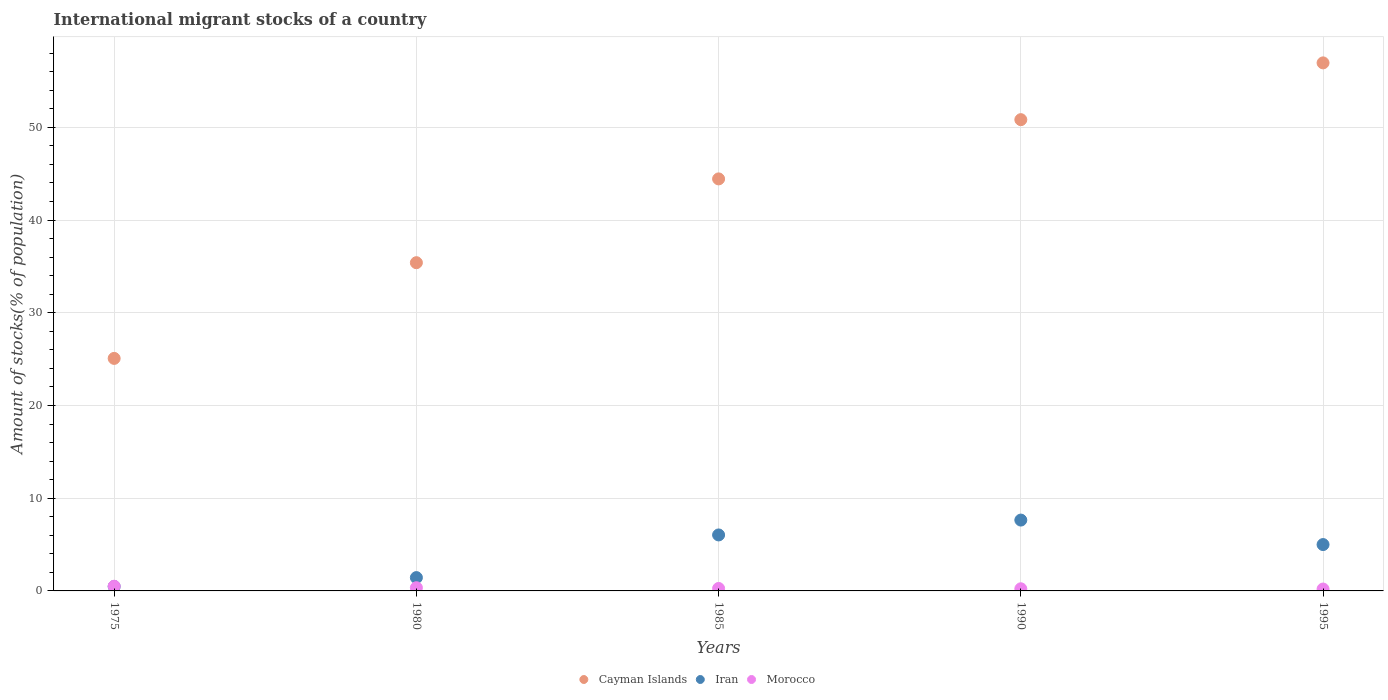How many different coloured dotlines are there?
Provide a short and direct response. 3. What is the amount of stocks in in Morocco in 1995?
Keep it short and to the point. 0.2. Across all years, what is the maximum amount of stocks in in Iran?
Your response must be concise. 7.64. Across all years, what is the minimum amount of stocks in in Cayman Islands?
Give a very brief answer. 25.08. In which year was the amount of stocks in in Cayman Islands minimum?
Your answer should be very brief. 1975. What is the total amount of stocks in in Morocco in the graph?
Your answer should be compact. 1.55. What is the difference between the amount of stocks in in Iran in 1975 and that in 1980?
Offer a terse response. -0.96. What is the difference between the amount of stocks in in Morocco in 1985 and the amount of stocks in in Iran in 1980?
Provide a short and direct response. -1.17. What is the average amount of stocks in in Iran per year?
Offer a very short reply. 4.12. In the year 1975, what is the difference between the amount of stocks in in Iran and amount of stocks in in Cayman Islands?
Provide a short and direct response. -24.6. In how many years, is the amount of stocks in in Iran greater than 34 %?
Your answer should be compact. 0. What is the ratio of the amount of stocks in in Cayman Islands in 1980 to that in 1995?
Offer a very short reply. 0.62. Is the difference between the amount of stocks in in Iran in 1975 and 1995 greater than the difference between the amount of stocks in in Cayman Islands in 1975 and 1995?
Your answer should be compact. Yes. What is the difference between the highest and the second highest amount of stocks in in Cayman Islands?
Provide a succinct answer. 6.12. What is the difference between the highest and the lowest amount of stocks in in Cayman Islands?
Your answer should be compact. 31.87. In how many years, is the amount of stocks in in Morocco greater than the average amount of stocks in in Morocco taken over all years?
Provide a short and direct response. 2. Is the sum of the amount of stocks in in Iran in 1985 and 1995 greater than the maximum amount of stocks in in Cayman Islands across all years?
Your answer should be very brief. No. Is it the case that in every year, the sum of the amount of stocks in in Iran and amount of stocks in in Cayman Islands  is greater than the amount of stocks in in Morocco?
Your response must be concise. Yes. How many dotlines are there?
Give a very brief answer. 3. What is the difference between two consecutive major ticks on the Y-axis?
Your answer should be very brief. 10. Are the values on the major ticks of Y-axis written in scientific E-notation?
Offer a very short reply. No. Does the graph contain grids?
Offer a terse response. Yes. How many legend labels are there?
Ensure brevity in your answer.  3. What is the title of the graph?
Make the answer very short. International migrant stocks of a country. Does "Mauritania" appear as one of the legend labels in the graph?
Make the answer very short. No. What is the label or title of the X-axis?
Provide a short and direct response. Years. What is the label or title of the Y-axis?
Your answer should be compact. Amount of stocks(% of population). What is the Amount of stocks(% of population) in Cayman Islands in 1975?
Offer a terse response. 25.08. What is the Amount of stocks(% of population) of Iran in 1975?
Your response must be concise. 0.48. What is the Amount of stocks(% of population) of Morocco in 1975?
Make the answer very short. 0.51. What is the Amount of stocks(% of population) of Cayman Islands in 1980?
Keep it short and to the point. 35.4. What is the Amount of stocks(% of population) in Iran in 1980?
Give a very brief answer. 1.44. What is the Amount of stocks(% of population) of Morocco in 1980?
Your answer should be compact. 0.34. What is the Amount of stocks(% of population) in Cayman Islands in 1985?
Your answer should be compact. 44.44. What is the Amount of stocks(% of population) in Iran in 1985?
Your response must be concise. 6.04. What is the Amount of stocks(% of population) in Morocco in 1985?
Your answer should be very brief. 0.27. What is the Amount of stocks(% of population) in Cayman Islands in 1990?
Keep it short and to the point. 50.83. What is the Amount of stocks(% of population) of Iran in 1990?
Your answer should be very brief. 7.64. What is the Amount of stocks(% of population) of Morocco in 1990?
Give a very brief answer. 0.23. What is the Amount of stocks(% of population) in Cayman Islands in 1995?
Your answer should be compact. 56.95. What is the Amount of stocks(% of population) in Iran in 1995?
Ensure brevity in your answer.  5. What is the Amount of stocks(% of population) of Morocco in 1995?
Provide a succinct answer. 0.2. Across all years, what is the maximum Amount of stocks(% of population) of Cayman Islands?
Ensure brevity in your answer.  56.95. Across all years, what is the maximum Amount of stocks(% of population) in Iran?
Provide a short and direct response. 7.64. Across all years, what is the maximum Amount of stocks(% of population) of Morocco?
Provide a short and direct response. 0.51. Across all years, what is the minimum Amount of stocks(% of population) in Cayman Islands?
Provide a short and direct response. 25.08. Across all years, what is the minimum Amount of stocks(% of population) in Iran?
Your answer should be very brief. 0.48. Across all years, what is the minimum Amount of stocks(% of population) of Morocco?
Ensure brevity in your answer.  0.2. What is the total Amount of stocks(% of population) of Cayman Islands in the graph?
Give a very brief answer. 212.69. What is the total Amount of stocks(% of population) of Iran in the graph?
Make the answer very short. 20.59. What is the total Amount of stocks(% of population) of Morocco in the graph?
Your answer should be very brief. 1.55. What is the difference between the Amount of stocks(% of population) of Cayman Islands in 1975 and that in 1980?
Your answer should be compact. -10.32. What is the difference between the Amount of stocks(% of population) in Iran in 1975 and that in 1980?
Make the answer very short. -0.96. What is the difference between the Amount of stocks(% of population) of Morocco in 1975 and that in 1980?
Provide a short and direct response. 0.16. What is the difference between the Amount of stocks(% of population) of Cayman Islands in 1975 and that in 1985?
Provide a succinct answer. -19.36. What is the difference between the Amount of stocks(% of population) of Iran in 1975 and that in 1985?
Provide a short and direct response. -5.56. What is the difference between the Amount of stocks(% of population) of Morocco in 1975 and that in 1985?
Make the answer very short. 0.24. What is the difference between the Amount of stocks(% of population) of Cayman Islands in 1975 and that in 1990?
Provide a short and direct response. -25.75. What is the difference between the Amount of stocks(% of population) in Iran in 1975 and that in 1990?
Give a very brief answer. -7.16. What is the difference between the Amount of stocks(% of population) in Morocco in 1975 and that in 1990?
Provide a succinct answer. 0.28. What is the difference between the Amount of stocks(% of population) of Cayman Islands in 1975 and that in 1995?
Offer a very short reply. -31.87. What is the difference between the Amount of stocks(% of population) of Iran in 1975 and that in 1995?
Ensure brevity in your answer.  -4.52. What is the difference between the Amount of stocks(% of population) of Morocco in 1975 and that in 1995?
Your answer should be very brief. 0.3. What is the difference between the Amount of stocks(% of population) in Cayman Islands in 1980 and that in 1985?
Make the answer very short. -9.04. What is the difference between the Amount of stocks(% of population) of Iran in 1980 and that in 1985?
Provide a succinct answer. -4.6. What is the difference between the Amount of stocks(% of population) of Morocco in 1980 and that in 1985?
Keep it short and to the point. 0.08. What is the difference between the Amount of stocks(% of population) in Cayman Islands in 1980 and that in 1990?
Your answer should be compact. -15.43. What is the difference between the Amount of stocks(% of population) in Iran in 1980 and that in 1990?
Give a very brief answer. -6.2. What is the difference between the Amount of stocks(% of population) in Morocco in 1980 and that in 1990?
Provide a short and direct response. 0.11. What is the difference between the Amount of stocks(% of population) in Cayman Islands in 1980 and that in 1995?
Your response must be concise. -21.55. What is the difference between the Amount of stocks(% of population) in Iran in 1980 and that in 1995?
Make the answer very short. -3.56. What is the difference between the Amount of stocks(% of population) of Morocco in 1980 and that in 1995?
Your answer should be very brief. 0.14. What is the difference between the Amount of stocks(% of population) of Cayman Islands in 1985 and that in 1990?
Provide a short and direct response. -6.39. What is the difference between the Amount of stocks(% of population) in Iran in 1985 and that in 1990?
Keep it short and to the point. -1.6. What is the difference between the Amount of stocks(% of population) of Morocco in 1985 and that in 1990?
Ensure brevity in your answer.  0.03. What is the difference between the Amount of stocks(% of population) of Cayman Islands in 1985 and that in 1995?
Make the answer very short. -12.51. What is the difference between the Amount of stocks(% of population) in Iran in 1985 and that in 1995?
Keep it short and to the point. 1.04. What is the difference between the Amount of stocks(% of population) in Morocco in 1985 and that in 1995?
Provide a succinct answer. 0.06. What is the difference between the Amount of stocks(% of population) of Cayman Islands in 1990 and that in 1995?
Offer a terse response. -6.12. What is the difference between the Amount of stocks(% of population) of Iran in 1990 and that in 1995?
Give a very brief answer. 2.64. What is the difference between the Amount of stocks(% of population) in Morocco in 1990 and that in 1995?
Provide a short and direct response. 0.03. What is the difference between the Amount of stocks(% of population) of Cayman Islands in 1975 and the Amount of stocks(% of population) of Iran in 1980?
Offer a terse response. 23.64. What is the difference between the Amount of stocks(% of population) in Cayman Islands in 1975 and the Amount of stocks(% of population) in Morocco in 1980?
Keep it short and to the point. 24.73. What is the difference between the Amount of stocks(% of population) in Iran in 1975 and the Amount of stocks(% of population) in Morocco in 1980?
Give a very brief answer. 0.14. What is the difference between the Amount of stocks(% of population) in Cayman Islands in 1975 and the Amount of stocks(% of population) in Iran in 1985?
Your response must be concise. 19.04. What is the difference between the Amount of stocks(% of population) of Cayman Islands in 1975 and the Amount of stocks(% of population) of Morocco in 1985?
Keep it short and to the point. 24.81. What is the difference between the Amount of stocks(% of population) of Iran in 1975 and the Amount of stocks(% of population) of Morocco in 1985?
Keep it short and to the point. 0.21. What is the difference between the Amount of stocks(% of population) in Cayman Islands in 1975 and the Amount of stocks(% of population) in Iran in 1990?
Offer a terse response. 17.44. What is the difference between the Amount of stocks(% of population) of Cayman Islands in 1975 and the Amount of stocks(% of population) of Morocco in 1990?
Your answer should be compact. 24.85. What is the difference between the Amount of stocks(% of population) in Iran in 1975 and the Amount of stocks(% of population) in Morocco in 1990?
Keep it short and to the point. 0.25. What is the difference between the Amount of stocks(% of population) of Cayman Islands in 1975 and the Amount of stocks(% of population) of Iran in 1995?
Keep it short and to the point. 20.08. What is the difference between the Amount of stocks(% of population) in Cayman Islands in 1975 and the Amount of stocks(% of population) in Morocco in 1995?
Provide a short and direct response. 24.87. What is the difference between the Amount of stocks(% of population) in Iran in 1975 and the Amount of stocks(% of population) in Morocco in 1995?
Make the answer very short. 0.28. What is the difference between the Amount of stocks(% of population) of Cayman Islands in 1980 and the Amount of stocks(% of population) of Iran in 1985?
Offer a terse response. 29.36. What is the difference between the Amount of stocks(% of population) of Cayman Islands in 1980 and the Amount of stocks(% of population) of Morocco in 1985?
Provide a succinct answer. 35.13. What is the difference between the Amount of stocks(% of population) of Iran in 1980 and the Amount of stocks(% of population) of Morocco in 1985?
Make the answer very short. 1.17. What is the difference between the Amount of stocks(% of population) in Cayman Islands in 1980 and the Amount of stocks(% of population) in Iran in 1990?
Make the answer very short. 27.76. What is the difference between the Amount of stocks(% of population) in Cayman Islands in 1980 and the Amount of stocks(% of population) in Morocco in 1990?
Provide a short and direct response. 35.17. What is the difference between the Amount of stocks(% of population) in Iran in 1980 and the Amount of stocks(% of population) in Morocco in 1990?
Your response must be concise. 1.21. What is the difference between the Amount of stocks(% of population) in Cayman Islands in 1980 and the Amount of stocks(% of population) in Iran in 1995?
Provide a short and direct response. 30.4. What is the difference between the Amount of stocks(% of population) of Cayman Islands in 1980 and the Amount of stocks(% of population) of Morocco in 1995?
Your answer should be very brief. 35.2. What is the difference between the Amount of stocks(% of population) of Iran in 1980 and the Amount of stocks(% of population) of Morocco in 1995?
Your answer should be very brief. 1.23. What is the difference between the Amount of stocks(% of population) in Cayman Islands in 1985 and the Amount of stocks(% of population) in Iran in 1990?
Provide a succinct answer. 36.8. What is the difference between the Amount of stocks(% of population) in Cayman Islands in 1985 and the Amount of stocks(% of population) in Morocco in 1990?
Your answer should be compact. 44.21. What is the difference between the Amount of stocks(% of population) of Iran in 1985 and the Amount of stocks(% of population) of Morocco in 1990?
Provide a short and direct response. 5.81. What is the difference between the Amount of stocks(% of population) in Cayman Islands in 1985 and the Amount of stocks(% of population) in Iran in 1995?
Keep it short and to the point. 39.44. What is the difference between the Amount of stocks(% of population) of Cayman Islands in 1985 and the Amount of stocks(% of population) of Morocco in 1995?
Offer a terse response. 44.23. What is the difference between the Amount of stocks(% of population) of Iran in 1985 and the Amount of stocks(% of population) of Morocco in 1995?
Your answer should be very brief. 5.83. What is the difference between the Amount of stocks(% of population) in Cayman Islands in 1990 and the Amount of stocks(% of population) in Iran in 1995?
Offer a terse response. 45.83. What is the difference between the Amount of stocks(% of population) in Cayman Islands in 1990 and the Amount of stocks(% of population) in Morocco in 1995?
Ensure brevity in your answer.  50.62. What is the difference between the Amount of stocks(% of population) in Iran in 1990 and the Amount of stocks(% of population) in Morocco in 1995?
Your answer should be compact. 7.44. What is the average Amount of stocks(% of population) of Cayman Islands per year?
Offer a terse response. 42.54. What is the average Amount of stocks(% of population) of Iran per year?
Keep it short and to the point. 4.12. What is the average Amount of stocks(% of population) of Morocco per year?
Offer a terse response. 0.31. In the year 1975, what is the difference between the Amount of stocks(% of population) in Cayman Islands and Amount of stocks(% of population) in Iran?
Provide a short and direct response. 24.6. In the year 1975, what is the difference between the Amount of stocks(% of population) in Cayman Islands and Amount of stocks(% of population) in Morocco?
Your response must be concise. 24.57. In the year 1975, what is the difference between the Amount of stocks(% of population) in Iran and Amount of stocks(% of population) in Morocco?
Provide a succinct answer. -0.03. In the year 1980, what is the difference between the Amount of stocks(% of population) in Cayman Islands and Amount of stocks(% of population) in Iran?
Make the answer very short. 33.96. In the year 1980, what is the difference between the Amount of stocks(% of population) in Cayman Islands and Amount of stocks(% of population) in Morocco?
Make the answer very short. 35.06. In the year 1980, what is the difference between the Amount of stocks(% of population) in Iran and Amount of stocks(% of population) in Morocco?
Give a very brief answer. 1.09. In the year 1985, what is the difference between the Amount of stocks(% of population) of Cayman Islands and Amount of stocks(% of population) of Iran?
Provide a short and direct response. 38.4. In the year 1985, what is the difference between the Amount of stocks(% of population) in Cayman Islands and Amount of stocks(% of population) in Morocco?
Give a very brief answer. 44.17. In the year 1985, what is the difference between the Amount of stocks(% of population) in Iran and Amount of stocks(% of population) in Morocco?
Make the answer very short. 5.77. In the year 1990, what is the difference between the Amount of stocks(% of population) in Cayman Islands and Amount of stocks(% of population) in Iran?
Your answer should be very brief. 43.19. In the year 1990, what is the difference between the Amount of stocks(% of population) in Cayman Islands and Amount of stocks(% of population) in Morocco?
Your response must be concise. 50.59. In the year 1990, what is the difference between the Amount of stocks(% of population) of Iran and Amount of stocks(% of population) of Morocco?
Ensure brevity in your answer.  7.41. In the year 1995, what is the difference between the Amount of stocks(% of population) in Cayman Islands and Amount of stocks(% of population) in Iran?
Provide a succinct answer. 51.95. In the year 1995, what is the difference between the Amount of stocks(% of population) in Cayman Islands and Amount of stocks(% of population) in Morocco?
Provide a succinct answer. 56.75. In the year 1995, what is the difference between the Amount of stocks(% of population) in Iran and Amount of stocks(% of population) in Morocco?
Make the answer very short. 4.8. What is the ratio of the Amount of stocks(% of population) of Cayman Islands in 1975 to that in 1980?
Keep it short and to the point. 0.71. What is the ratio of the Amount of stocks(% of population) in Iran in 1975 to that in 1980?
Make the answer very short. 0.33. What is the ratio of the Amount of stocks(% of population) in Morocco in 1975 to that in 1980?
Ensure brevity in your answer.  1.47. What is the ratio of the Amount of stocks(% of population) in Cayman Islands in 1975 to that in 1985?
Provide a short and direct response. 0.56. What is the ratio of the Amount of stocks(% of population) of Iran in 1975 to that in 1985?
Make the answer very short. 0.08. What is the ratio of the Amount of stocks(% of population) of Morocco in 1975 to that in 1985?
Make the answer very short. 1.91. What is the ratio of the Amount of stocks(% of population) of Cayman Islands in 1975 to that in 1990?
Ensure brevity in your answer.  0.49. What is the ratio of the Amount of stocks(% of population) in Iran in 1975 to that in 1990?
Ensure brevity in your answer.  0.06. What is the ratio of the Amount of stocks(% of population) of Morocco in 1975 to that in 1990?
Your response must be concise. 2.2. What is the ratio of the Amount of stocks(% of population) in Cayman Islands in 1975 to that in 1995?
Your response must be concise. 0.44. What is the ratio of the Amount of stocks(% of population) in Iran in 1975 to that in 1995?
Offer a very short reply. 0.1. What is the ratio of the Amount of stocks(% of population) of Morocco in 1975 to that in 1995?
Provide a short and direct response. 2.49. What is the ratio of the Amount of stocks(% of population) in Cayman Islands in 1980 to that in 1985?
Your answer should be very brief. 0.8. What is the ratio of the Amount of stocks(% of population) of Iran in 1980 to that in 1985?
Offer a very short reply. 0.24. What is the ratio of the Amount of stocks(% of population) in Morocco in 1980 to that in 1985?
Your response must be concise. 1.3. What is the ratio of the Amount of stocks(% of population) in Cayman Islands in 1980 to that in 1990?
Ensure brevity in your answer.  0.7. What is the ratio of the Amount of stocks(% of population) of Iran in 1980 to that in 1990?
Provide a succinct answer. 0.19. What is the ratio of the Amount of stocks(% of population) in Morocco in 1980 to that in 1990?
Offer a terse response. 1.49. What is the ratio of the Amount of stocks(% of population) in Cayman Islands in 1980 to that in 1995?
Offer a very short reply. 0.62. What is the ratio of the Amount of stocks(% of population) in Iran in 1980 to that in 1995?
Ensure brevity in your answer.  0.29. What is the ratio of the Amount of stocks(% of population) of Morocco in 1980 to that in 1995?
Provide a succinct answer. 1.69. What is the ratio of the Amount of stocks(% of population) in Cayman Islands in 1985 to that in 1990?
Ensure brevity in your answer.  0.87. What is the ratio of the Amount of stocks(% of population) in Iran in 1985 to that in 1990?
Your answer should be very brief. 0.79. What is the ratio of the Amount of stocks(% of population) of Morocco in 1985 to that in 1990?
Your response must be concise. 1.15. What is the ratio of the Amount of stocks(% of population) of Cayman Islands in 1985 to that in 1995?
Keep it short and to the point. 0.78. What is the ratio of the Amount of stocks(% of population) of Iran in 1985 to that in 1995?
Make the answer very short. 1.21. What is the ratio of the Amount of stocks(% of population) of Morocco in 1985 to that in 1995?
Offer a very short reply. 1.3. What is the ratio of the Amount of stocks(% of population) of Cayman Islands in 1990 to that in 1995?
Offer a terse response. 0.89. What is the ratio of the Amount of stocks(% of population) of Iran in 1990 to that in 1995?
Your answer should be compact. 1.53. What is the ratio of the Amount of stocks(% of population) of Morocco in 1990 to that in 1995?
Your answer should be compact. 1.13. What is the difference between the highest and the second highest Amount of stocks(% of population) in Cayman Islands?
Ensure brevity in your answer.  6.12. What is the difference between the highest and the second highest Amount of stocks(% of population) of Iran?
Provide a succinct answer. 1.6. What is the difference between the highest and the second highest Amount of stocks(% of population) of Morocco?
Ensure brevity in your answer.  0.16. What is the difference between the highest and the lowest Amount of stocks(% of population) of Cayman Islands?
Give a very brief answer. 31.87. What is the difference between the highest and the lowest Amount of stocks(% of population) of Iran?
Offer a terse response. 7.16. What is the difference between the highest and the lowest Amount of stocks(% of population) in Morocco?
Your response must be concise. 0.3. 